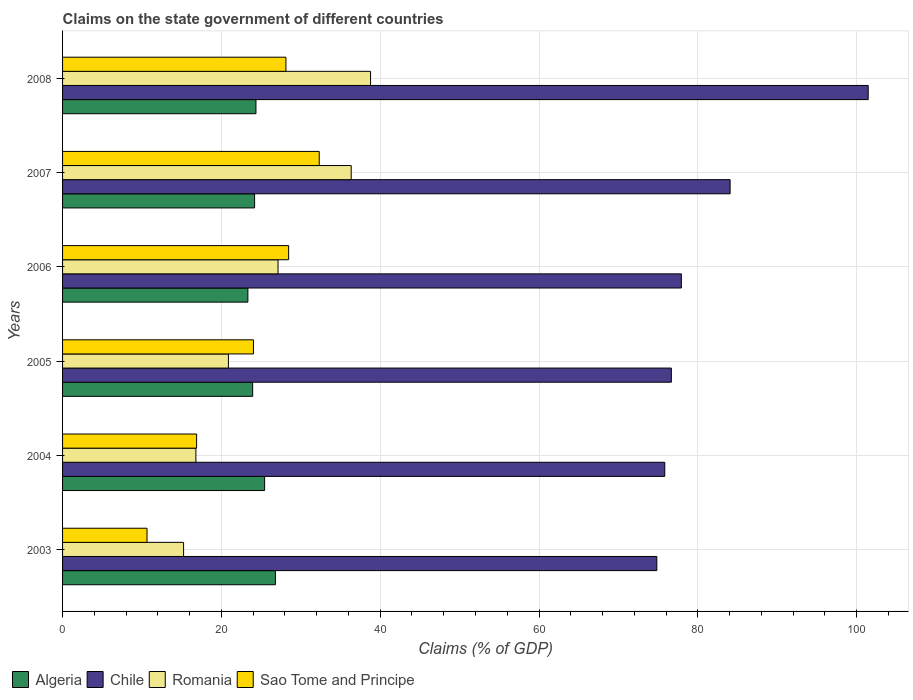How many groups of bars are there?
Your response must be concise. 6. Are the number of bars per tick equal to the number of legend labels?
Keep it short and to the point. Yes. How many bars are there on the 2nd tick from the top?
Your response must be concise. 4. What is the label of the 6th group of bars from the top?
Your answer should be compact. 2003. In how many cases, is the number of bars for a given year not equal to the number of legend labels?
Give a very brief answer. 0. What is the percentage of GDP claimed on the state government in Algeria in 2006?
Provide a short and direct response. 23.33. Across all years, what is the maximum percentage of GDP claimed on the state government in Algeria?
Your answer should be compact. 26.8. Across all years, what is the minimum percentage of GDP claimed on the state government in Algeria?
Your answer should be very brief. 23.33. In which year was the percentage of GDP claimed on the state government in Sao Tome and Principe maximum?
Give a very brief answer. 2007. What is the total percentage of GDP claimed on the state government in Romania in the graph?
Your response must be concise. 155.18. What is the difference between the percentage of GDP claimed on the state government in Sao Tome and Principe in 2007 and that in 2008?
Offer a very short reply. 4.2. What is the difference between the percentage of GDP claimed on the state government in Algeria in 2004 and the percentage of GDP claimed on the state government in Sao Tome and Principe in 2007?
Keep it short and to the point. -6.88. What is the average percentage of GDP claimed on the state government in Algeria per year?
Provide a short and direct response. 24.68. In the year 2004, what is the difference between the percentage of GDP claimed on the state government in Algeria and percentage of GDP claimed on the state government in Sao Tome and Principe?
Give a very brief answer. 8.56. What is the ratio of the percentage of GDP claimed on the state government in Romania in 2004 to that in 2007?
Provide a short and direct response. 0.46. Is the percentage of GDP claimed on the state government in Sao Tome and Principe in 2003 less than that in 2007?
Your answer should be compact. Yes. What is the difference between the highest and the second highest percentage of GDP claimed on the state government in Sao Tome and Principe?
Keep it short and to the point. 3.85. What is the difference between the highest and the lowest percentage of GDP claimed on the state government in Romania?
Provide a short and direct response. 23.55. In how many years, is the percentage of GDP claimed on the state government in Algeria greater than the average percentage of GDP claimed on the state government in Algeria taken over all years?
Provide a succinct answer. 2. Is the sum of the percentage of GDP claimed on the state government in Romania in 2004 and 2005 greater than the maximum percentage of GDP claimed on the state government in Algeria across all years?
Your answer should be compact. Yes. Is it the case that in every year, the sum of the percentage of GDP claimed on the state government in Chile and percentage of GDP claimed on the state government in Sao Tome and Principe is greater than the sum of percentage of GDP claimed on the state government in Romania and percentage of GDP claimed on the state government in Algeria?
Your answer should be very brief. Yes. What does the 3rd bar from the top in 2008 represents?
Offer a terse response. Chile. What does the 1st bar from the bottom in 2007 represents?
Offer a very short reply. Algeria. How many bars are there?
Keep it short and to the point. 24. Are all the bars in the graph horizontal?
Provide a succinct answer. Yes. How many years are there in the graph?
Your answer should be very brief. 6. Are the values on the major ticks of X-axis written in scientific E-notation?
Ensure brevity in your answer.  No. Does the graph contain grids?
Provide a short and direct response. Yes. Where does the legend appear in the graph?
Your answer should be compact. Bottom left. How many legend labels are there?
Offer a very short reply. 4. How are the legend labels stacked?
Ensure brevity in your answer.  Horizontal. What is the title of the graph?
Your response must be concise. Claims on the state government of different countries. What is the label or title of the X-axis?
Your response must be concise. Claims (% of GDP). What is the label or title of the Y-axis?
Offer a terse response. Years. What is the Claims (% of GDP) of Algeria in 2003?
Make the answer very short. 26.8. What is the Claims (% of GDP) in Chile in 2003?
Provide a succinct answer. 74.83. What is the Claims (% of GDP) in Romania in 2003?
Offer a terse response. 15.24. What is the Claims (% of GDP) of Sao Tome and Principe in 2003?
Offer a very short reply. 10.64. What is the Claims (% of GDP) in Algeria in 2004?
Your answer should be very brief. 25.44. What is the Claims (% of GDP) in Chile in 2004?
Offer a very short reply. 75.83. What is the Claims (% of GDP) in Romania in 2004?
Your response must be concise. 16.79. What is the Claims (% of GDP) in Sao Tome and Principe in 2004?
Offer a terse response. 16.88. What is the Claims (% of GDP) in Algeria in 2005?
Offer a terse response. 23.94. What is the Claims (% of GDP) in Chile in 2005?
Your answer should be compact. 76.66. What is the Claims (% of GDP) of Romania in 2005?
Your response must be concise. 20.89. What is the Claims (% of GDP) of Sao Tome and Principe in 2005?
Offer a very short reply. 24.04. What is the Claims (% of GDP) of Algeria in 2006?
Your response must be concise. 23.33. What is the Claims (% of GDP) in Chile in 2006?
Ensure brevity in your answer.  77.92. What is the Claims (% of GDP) in Romania in 2006?
Keep it short and to the point. 27.13. What is the Claims (% of GDP) in Sao Tome and Principe in 2006?
Make the answer very short. 28.47. What is the Claims (% of GDP) of Algeria in 2007?
Make the answer very short. 24.18. What is the Claims (% of GDP) in Chile in 2007?
Your answer should be compact. 84.06. What is the Claims (% of GDP) in Romania in 2007?
Provide a succinct answer. 36.35. What is the Claims (% of GDP) in Sao Tome and Principe in 2007?
Offer a terse response. 32.32. What is the Claims (% of GDP) of Algeria in 2008?
Offer a terse response. 24.35. What is the Claims (% of GDP) in Chile in 2008?
Your response must be concise. 101.45. What is the Claims (% of GDP) of Romania in 2008?
Offer a terse response. 38.78. What is the Claims (% of GDP) of Sao Tome and Principe in 2008?
Provide a succinct answer. 28.13. Across all years, what is the maximum Claims (% of GDP) of Algeria?
Ensure brevity in your answer.  26.8. Across all years, what is the maximum Claims (% of GDP) in Chile?
Your answer should be compact. 101.45. Across all years, what is the maximum Claims (% of GDP) in Romania?
Provide a succinct answer. 38.78. Across all years, what is the maximum Claims (% of GDP) of Sao Tome and Principe?
Offer a very short reply. 32.32. Across all years, what is the minimum Claims (% of GDP) of Algeria?
Your answer should be very brief. 23.33. Across all years, what is the minimum Claims (% of GDP) of Chile?
Make the answer very short. 74.83. Across all years, what is the minimum Claims (% of GDP) in Romania?
Your answer should be compact. 15.24. Across all years, what is the minimum Claims (% of GDP) in Sao Tome and Principe?
Your answer should be very brief. 10.64. What is the total Claims (% of GDP) of Algeria in the graph?
Offer a terse response. 148.05. What is the total Claims (% of GDP) of Chile in the graph?
Provide a short and direct response. 490.76. What is the total Claims (% of GDP) of Romania in the graph?
Make the answer very short. 155.18. What is the total Claims (% of GDP) in Sao Tome and Principe in the graph?
Your response must be concise. 140.47. What is the difference between the Claims (% of GDP) of Algeria in 2003 and that in 2004?
Offer a very short reply. 1.36. What is the difference between the Claims (% of GDP) in Chile in 2003 and that in 2004?
Keep it short and to the point. -1. What is the difference between the Claims (% of GDP) in Romania in 2003 and that in 2004?
Make the answer very short. -1.55. What is the difference between the Claims (% of GDP) in Sao Tome and Principe in 2003 and that in 2004?
Offer a terse response. -6.24. What is the difference between the Claims (% of GDP) of Algeria in 2003 and that in 2005?
Give a very brief answer. 2.86. What is the difference between the Claims (% of GDP) in Chile in 2003 and that in 2005?
Give a very brief answer. -1.83. What is the difference between the Claims (% of GDP) of Romania in 2003 and that in 2005?
Give a very brief answer. -5.65. What is the difference between the Claims (% of GDP) of Sao Tome and Principe in 2003 and that in 2005?
Give a very brief answer. -13.4. What is the difference between the Claims (% of GDP) of Algeria in 2003 and that in 2006?
Ensure brevity in your answer.  3.47. What is the difference between the Claims (% of GDP) in Chile in 2003 and that in 2006?
Give a very brief answer. -3.09. What is the difference between the Claims (% of GDP) in Romania in 2003 and that in 2006?
Provide a short and direct response. -11.89. What is the difference between the Claims (% of GDP) of Sao Tome and Principe in 2003 and that in 2006?
Your answer should be compact. -17.83. What is the difference between the Claims (% of GDP) in Algeria in 2003 and that in 2007?
Give a very brief answer. 2.62. What is the difference between the Claims (% of GDP) in Chile in 2003 and that in 2007?
Offer a terse response. -9.23. What is the difference between the Claims (% of GDP) in Romania in 2003 and that in 2007?
Ensure brevity in your answer.  -21.11. What is the difference between the Claims (% of GDP) in Sao Tome and Principe in 2003 and that in 2007?
Provide a short and direct response. -21.69. What is the difference between the Claims (% of GDP) in Algeria in 2003 and that in 2008?
Provide a short and direct response. 2.45. What is the difference between the Claims (% of GDP) in Chile in 2003 and that in 2008?
Ensure brevity in your answer.  -26.62. What is the difference between the Claims (% of GDP) in Romania in 2003 and that in 2008?
Offer a very short reply. -23.55. What is the difference between the Claims (% of GDP) in Sao Tome and Principe in 2003 and that in 2008?
Offer a very short reply. -17.49. What is the difference between the Claims (% of GDP) in Algeria in 2004 and that in 2005?
Your response must be concise. 1.51. What is the difference between the Claims (% of GDP) of Chile in 2004 and that in 2005?
Provide a short and direct response. -0.83. What is the difference between the Claims (% of GDP) of Romania in 2004 and that in 2005?
Give a very brief answer. -4.1. What is the difference between the Claims (% of GDP) in Sao Tome and Principe in 2004 and that in 2005?
Your answer should be compact. -7.16. What is the difference between the Claims (% of GDP) of Algeria in 2004 and that in 2006?
Provide a short and direct response. 2.11. What is the difference between the Claims (% of GDP) in Chile in 2004 and that in 2006?
Your answer should be compact. -2.09. What is the difference between the Claims (% of GDP) of Romania in 2004 and that in 2006?
Make the answer very short. -10.34. What is the difference between the Claims (% of GDP) in Sao Tome and Principe in 2004 and that in 2006?
Offer a terse response. -11.59. What is the difference between the Claims (% of GDP) of Algeria in 2004 and that in 2007?
Keep it short and to the point. 1.26. What is the difference between the Claims (% of GDP) of Chile in 2004 and that in 2007?
Your answer should be very brief. -8.23. What is the difference between the Claims (% of GDP) in Romania in 2004 and that in 2007?
Ensure brevity in your answer.  -19.56. What is the difference between the Claims (% of GDP) in Sao Tome and Principe in 2004 and that in 2007?
Keep it short and to the point. -15.44. What is the difference between the Claims (% of GDP) in Algeria in 2004 and that in 2008?
Provide a succinct answer. 1.09. What is the difference between the Claims (% of GDP) of Chile in 2004 and that in 2008?
Provide a succinct answer. -25.62. What is the difference between the Claims (% of GDP) of Romania in 2004 and that in 2008?
Offer a very short reply. -22. What is the difference between the Claims (% of GDP) of Sao Tome and Principe in 2004 and that in 2008?
Offer a terse response. -11.25. What is the difference between the Claims (% of GDP) in Algeria in 2005 and that in 2006?
Offer a terse response. 0.6. What is the difference between the Claims (% of GDP) of Chile in 2005 and that in 2006?
Make the answer very short. -1.26. What is the difference between the Claims (% of GDP) of Romania in 2005 and that in 2006?
Make the answer very short. -6.25. What is the difference between the Claims (% of GDP) in Sao Tome and Principe in 2005 and that in 2006?
Provide a short and direct response. -4.43. What is the difference between the Claims (% of GDP) of Algeria in 2005 and that in 2007?
Offer a very short reply. -0.24. What is the difference between the Claims (% of GDP) in Chile in 2005 and that in 2007?
Offer a terse response. -7.4. What is the difference between the Claims (% of GDP) of Romania in 2005 and that in 2007?
Keep it short and to the point. -15.46. What is the difference between the Claims (% of GDP) in Sao Tome and Principe in 2005 and that in 2007?
Give a very brief answer. -8.29. What is the difference between the Claims (% of GDP) of Algeria in 2005 and that in 2008?
Keep it short and to the point. -0.41. What is the difference between the Claims (% of GDP) of Chile in 2005 and that in 2008?
Provide a succinct answer. -24.79. What is the difference between the Claims (% of GDP) of Romania in 2005 and that in 2008?
Your answer should be compact. -17.9. What is the difference between the Claims (% of GDP) in Sao Tome and Principe in 2005 and that in 2008?
Offer a terse response. -4.09. What is the difference between the Claims (% of GDP) in Algeria in 2006 and that in 2007?
Your answer should be compact. -0.85. What is the difference between the Claims (% of GDP) in Chile in 2006 and that in 2007?
Your response must be concise. -6.14. What is the difference between the Claims (% of GDP) of Romania in 2006 and that in 2007?
Ensure brevity in your answer.  -9.21. What is the difference between the Claims (% of GDP) of Sao Tome and Principe in 2006 and that in 2007?
Ensure brevity in your answer.  -3.85. What is the difference between the Claims (% of GDP) of Algeria in 2006 and that in 2008?
Ensure brevity in your answer.  -1.02. What is the difference between the Claims (% of GDP) in Chile in 2006 and that in 2008?
Give a very brief answer. -23.53. What is the difference between the Claims (% of GDP) in Romania in 2006 and that in 2008?
Provide a short and direct response. -11.65. What is the difference between the Claims (% of GDP) in Sao Tome and Principe in 2006 and that in 2008?
Your answer should be compact. 0.34. What is the difference between the Claims (% of GDP) in Algeria in 2007 and that in 2008?
Offer a terse response. -0.17. What is the difference between the Claims (% of GDP) of Chile in 2007 and that in 2008?
Provide a succinct answer. -17.39. What is the difference between the Claims (% of GDP) in Romania in 2007 and that in 2008?
Keep it short and to the point. -2.44. What is the difference between the Claims (% of GDP) of Sao Tome and Principe in 2007 and that in 2008?
Make the answer very short. 4.2. What is the difference between the Claims (% of GDP) in Algeria in 2003 and the Claims (% of GDP) in Chile in 2004?
Give a very brief answer. -49.03. What is the difference between the Claims (% of GDP) of Algeria in 2003 and the Claims (% of GDP) of Romania in 2004?
Offer a very short reply. 10.01. What is the difference between the Claims (% of GDP) in Algeria in 2003 and the Claims (% of GDP) in Sao Tome and Principe in 2004?
Offer a terse response. 9.92. What is the difference between the Claims (% of GDP) in Chile in 2003 and the Claims (% of GDP) in Romania in 2004?
Your answer should be compact. 58.04. What is the difference between the Claims (% of GDP) of Chile in 2003 and the Claims (% of GDP) of Sao Tome and Principe in 2004?
Ensure brevity in your answer.  57.95. What is the difference between the Claims (% of GDP) in Romania in 2003 and the Claims (% of GDP) in Sao Tome and Principe in 2004?
Ensure brevity in your answer.  -1.64. What is the difference between the Claims (% of GDP) of Algeria in 2003 and the Claims (% of GDP) of Chile in 2005?
Your answer should be very brief. -49.86. What is the difference between the Claims (% of GDP) of Algeria in 2003 and the Claims (% of GDP) of Romania in 2005?
Give a very brief answer. 5.92. What is the difference between the Claims (% of GDP) in Algeria in 2003 and the Claims (% of GDP) in Sao Tome and Principe in 2005?
Give a very brief answer. 2.77. What is the difference between the Claims (% of GDP) of Chile in 2003 and the Claims (% of GDP) of Romania in 2005?
Provide a short and direct response. 53.95. What is the difference between the Claims (% of GDP) in Chile in 2003 and the Claims (% of GDP) in Sao Tome and Principe in 2005?
Ensure brevity in your answer.  50.8. What is the difference between the Claims (% of GDP) of Romania in 2003 and the Claims (% of GDP) of Sao Tome and Principe in 2005?
Your answer should be compact. -8.8. What is the difference between the Claims (% of GDP) of Algeria in 2003 and the Claims (% of GDP) of Chile in 2006?
Your response must be concise. -51.12. What is the difference between the Claims (% of GDP) in Algeria in 2003 and the Claims (% of GDP) in Romania in 2006?
Your answer should be compact. -0.33. What is the difference between the Claims (% of GDP) in Algeria in 2003 and the Claims (% of GDP) in Sao Tome and Principe in 2006?
Ensure brevity in your answer.  -1.67. What is the difference between the Claims (% of GDP) of Chile in 2003 and the Claims (% of GDP) of Romania in 2006?
Your answer should be compact. 47.7. What is the difference between the Claims (% of GDP) of Chile in 2003 and the Claims (% of GDP) of Sao Tome and Principe in 2006?
Your answer should be very brief. 46.36. What is the difference between the Claims (% of GDP) of Romania in 2003 and the Claims (% of GDP) of Sao Tome and Principe in 2006?
Your response must be concise. -13.23. What is the difference between the Claims (% of GDP) of Algeria in 2003 and the Claims (% of GDP) of Chile in 2007?
Your answer should be compact. -57.26. What is the difference between the Claims (% of GDP) in Algeria in 2003 and the Claims (% of GDP) in Romania in 2007?
Provide a succinct answer. -9.54. What is the difference between the Claims (% of GDP) in Algeria in 2003 and the Claims (% of GDP) in Sao Tome and Principe in 2007?
Your answer should be compact. -5.52. What is the difference between the Claims (% of GDP) of Chile in 2003 and the Claims (% of GDP) of Romania in 2007?
Your answer should be compact. 38.49. What is the difference between the Claims (% of GDP) in Chile in 2003 and the Claims (% of GDP) in Sao Tome and Principe in 2007?
Give a very brief answer. 42.51. What is the difference between the Claims (% of GDP) of Romania in 2003 and the Claims (% of GDP) of Sao Tome and Principe in 2007?
Give a very brief answer. -17.08. What is the difference between the Claims (% of GDP) in Algeria in 2003 and the Claims (% of GDP) in Chile in 2008?
Offer a terse response. -74.65. What is the difference between the Claims (% of GDP) in Algeria in 2003 and the Claims (% of GDP) in Romania in 2008?
Your response must be concise. -11.98. What is the difference between the Claims (% of GDP) of Algeria in 2003 and the Claims (% of GDP) of Sao Tome and Principe in 2008?
Keep it short and to the point. -1.32. What is the difference between the Claims (% of GDP) of Chile in 2003 and the Claims (% of GDP) of Romania in 2008?
Ensure brevity in your answer.  36.05. What is the difference between the Claims (% of GDP) in Chile in 2003 and the Claims (% of GDP) in Sao Tome and Principe in 2008?
Give a very brief answer. 46.71. What is the difference between the Claims (% of GDP) of Romania in 2003 and the Claims (% of GDP) of Sao Tome and Principe in 2008?
Provide a short and direct response. -12.89. What is the difference between the Claims (% of GDP) in Algeria in 2004 and the Claims (% of GDP) in Chile in 2005?
Keep it short and to the point. -51.22. What is the difference between the Claims (% of GDP) of Algeria in 2004 and the Claims (% of GDP) of Romania in 2005?
Provide a succinct answer. 4.56. What is the difference between the Claims (% of GDP) in Algeria in 2004 and the Claims (% of GDP) in Sao Tome and Principe in 2005?
Your answer should be very brief. 1.41. What is the difference between the Claims (% of GDP) in Chile in 2004 and the Claims (% of GDP) in Romania in 2005?
Provide a short and direct response. 54.94. What is the difference between the Claims (% of GDP) of Chile in 2004 and the Claims (% of GDP) of Sao Tome and Principe in 2005?
Provide a short and direct response. 51.8. What is the difference between the Claims (% of GDP) in Romania in 2004 and the Claims (% of GDP) in Sao Tome and Principe in 2005?
Provide a short and direct response. -7.25. What is the difference between the Claims (% of GDP) in Algeria in 2004 and the Claims (% of GDP) in Chile in 2006?
Offer a very short reply. -52.48. What is the difference between the Claims (% of GDP) in Algeria in 2004 and the Claims (% of GDP) in Romania in 2006?
Provide a short and direct response. -1.69. What is the difference between the Claims (% of GDP) of Algeria in 2004 and the Claims (% of GDP) of Sao Tome and Principe in 2006?
Provide a short and direct response. -3.03. What is the difference between the Claims (% of GDP) of Chile in 2004 and the Claims (% of GDP) of Romania in 2006?
Give a very brief answer. 48.7. What is the difference between the Claims (% of GDP) in Chile in 2004 and the Claims (% of GDP) in Sao Tome and Principe in 2006?
Keep it short and to the point. 47.36. What is the difference between the Claims (% of GDP) in Romania in 2004 and the Claims (% of GDP) in Sao Tome and Principe in 2006?
Provide a succinct answer. -11.68. What is the difference between the Claims (% of GDP) of Algeria in 2004 and the Claims (% of GDP) of Chile in 2007?
Give a very brief answer. -58.62. What is the difference between the Claims (% of GDP) in Algeria in 2004 and the Claims (% of GDP) in Romania in 2007?
Keep it short and to the point. -10.9. What is the difference between the Claims (% of GDP) of Algeria in 2004 and the Claims (% of GDP) of Sao Tome and Principe in 2007?
Ensure brevity in your answer.  -6.88. What is the difference between the Claims (% of GDP) in Chile in 2004 and the Claims (% of GDP) in Romania in 2007?
Your response must be concise. 39.48. What is the difference between the Claims (% of GDP) in Chile in 2004 and the Claims (% of GDP) in Sao Tome and Principe in 2007?
Keep it short and to the point. 43.51. What is the difference between the Claims (% of GDP) of Romania in 2004 and the Claims (% of GDP) of Sao Tome and Principe in 2007?
Give a very brief answer. -15.53. What is the difference between the Claims (% of GDP) in Algeria in 2004 and the Claims (% of GDP) in Chile in 2008?
Make the answer very short. -76.01. What is the difference between the Claims (% of GDP) in Algeria in 2004 and the Claims (% of GDP) in Romania in 2008?
Provide a succinct answer. -13.34. What is the difference between the Claims (% of GDP) of Algeria in 2004 and the Claims (% of GDP) of Sao Tome and Principe in 2008?
Provide a short and direct response. -2.68. What is the difference between the Claims (% of GDP) in Chile in 2004 and the Claims (% of GDP) in Romania in 2008?
Keep it short and to the point. 37.05. What is the difference between the Claims (% of GDP) of Chile in 2004 and the Claims (% of GDP) of Sao Tome and Principe in 2008?
Provide a short and direct response. 47.71. What is the difference between the Claims (% of GDP) of Romania in 2004 and the Claims (% of GDP) of Sao Tome and Principe in 2008?
Give a very brief answer. -11.34. What is the difference between the Claims (% of GDP) of Algeria in 2005 and the Claims (% of GDP) of Chile in 2006?
Ensure brevity in your answer.  -53.98. What is the difference between the Claims (% of GDP) of Algeria in 2005 and the Claims (% of GDP) of Romania in 2006?
Offer a very short reply. -3.19. What is the difference between the Claims (% of GDP) in Algeria in 2005 and the Claims (% of GDP) in Sao Tome and Principe in 2006?
Provide a short and direct response. -4.53. What is the difference between the Claims (% of GDP) of Chile in 2005 and the Claims (% of GDP) of Romania in 2006?
Your response must be concise. 49.53. What is the difference between the Claims (% of GDP) of Chile in 2005 and the Claims (% of GDP) of Sao Tome and Principe in 2006?
Offer a terse response. 48.19. What is the difference between the Claims (% of GDP) of Romania in 2005 and the Claims (% of GDP) of Sao Tome and Principe in 2006?
Keep it short and to the point. -7.58. What is the difference between the Claims (% of GDP) of Algeria in 2005 and the Claims (% of GDP) of Chile in 2007?
Make the answer very short. -60.12. What is the difference between the Claims (% of GDP) of Algeria in 2005 and the Claims (% of GDP) of Romania in 2007?
Make the answer very short. -12.41. What is the difference between the Claims (% of GDP) of Algeria in 2005 and the Claims (% of GDP) of Sao Tome and Principe in 2007?
Your response must be concise. -8.38. What is the difference between the Claims (% of GDP) in Chile in 2005 and the Claims (% of GDP) in Romania in 2007?
Make the answer very short. 40.31. What is the difference between the Claims (% of GDP) of Chile in 2005 and the Claims (% of GDP) of Sao Tome and Principe in 2007?
Offer a terse response. 44.34. What is the difference between the Claims (% of GDP) of Romania in 2005 and the Claims (% of GDP) of Sao Tome and Principe in 2007?
Offer a terse response. -11.44. What is the difference between the Claims (% of GDP) of Algeria in 2005 and the Claims (% of GDP) of Chile in 2008?
Provide a short and direct response. -77.51. What is the difference between the Claims (% of GDP) of Algeria in 2005 and the Claims (% of GDP) of Romania in 2008?
Offer a very short reply. -14.85. What is the difference between the Claims (% of GDP) in Algeria in 2005 and the Claims (% of GDP) in Sao Tome and Principe in 2008?
Offer a terse response. -4.19. What is the difference between the Claims (% of GDP) in Chile in 2005 and the Claims (% of GDP) in Romania in 2008?
Provide a succinct answer. 37.88. What is the difference between the Claims (% of GDP) of Chile in 2005 and the Claims (% of GDP) of Sao Tome and Principe in 2008?
Ensure brevity in your answer.  48.54. What is the difference between the Claims (% of GDP) of Romania in 2005 and the Claims (% of GDP) of Sao Tome and Principe in 2008?
Keep it short and to the point. -7.24. What is the difference between the Claims (% of GDP) in Algeria in 2006 and the Claims (% of GDP) in Chile in 2007?
Your response must be concise. -60.73. What is the difference between the Claims (% of GDP) of Algeria in 2006 and the Claims (% of GDP) of Romania in 2007?
Offer a very short reply. -13.01. What is the difference between the Claims (% of GDP) of Algeria in 2006 and the Claims (% of GDP) of Sao Tome and Principe in 2007?
Offer a terse response. -8.99. What is the difference between the Claims (% of GDP) of Chile in 2006 and the Claims (% of GDP) of Romania in 2007?
Ensure brevity in your answer.  41.58. What is the difference between the Claims (% of GDP) of Chile in 2006 and the Claims (% of GDP) of Sao Tome and Principe in 2007?
Your answer should be compact. 45.6. What is the difference between the Claims (% of GDP) of Romania in 2006 and the Claims (% of GDP) of Sao Tome and Principe in 2007?
Make the answer very short. -5.19. What is the difference between the Claims (% of GDP) in Algeria in 2006 and the Claims (% of GDP) in Chile in 2008?
Your response must be concise. -78.12. What is the difference between the Claims (% of GDP) of Algeria in 2006 and the Claims (% of GDP) of Romania in 2008?
Keep it short and to the point. -15.45. What is the difference between the Claims (% of GDP) in Algeria in 2006 and the Claims (% of GDP) in Sao Tome and Principe in 2008?
Your response must be concise. -4.79. What is the difference between the Claims (% of GDP) in Chile in 2006 and the Claims (% of GDP) in Romania in 2008?
Make the answer very short. 39.14. What is the difference between the Claims (% of GDP) in Chile in 2006 and the Claims (% of GDP) in Sao Tome and Principe in 2008?
Provide a short and direct response. 49.8. What is the difference between the Claims (% of GDP) in Romania in 2006 and the Claims (% of GDP) in Sao Tome and Principe in 2008?
Offer a terse response. -0.99. What is the difference between the Claims (% of GDP) in Algeria in 2007 and the Claims (% of GDP) in Chile in 2008?
Your response must be concise. -77.27. What is the difference between the Claims (% of GDP) of Algeria in 2007 and the Claims (% of GDP) of Romania in 2008?
Keep it short and to the point. -14.6. What is the difference between the Claims (% of GDP) of Algeria in 2007 and the Claims (% of GDP) of Sao Tome and Principe in 2008?
Keep it short and to the point. -3.94. What is the difference between the Claims (% of GDP) in Chile in 2007 and the Claims (% of GDP) in Romania in 2008?
Your answer should be compact. 45.28. What is the difference between the Claims (% of GDP) in Chile in 2007 and the Claims (% of GDP) in Sao Tome and Principe in 2008?
Keep it short and to the point. 55.94. What is the difference between the Claims (% of GDP) of Romania in 2007 and the Claims (% of GDP) of Sao Tome and Principe in 2008?
Your answer should be very brief. 8.22. What is the average Claims (% of GDP) in Algeria per year?
Make the answer very short. 24.68. What is the average Claims (% of GDP) of Chile per year?
Provide a succinct answer. 81.79. What is the average Claims (% of GDP) of Romania per year?
Offer a terse response. 25.86. What is the average Claims (% of GDP) in Sao Tome and Principe per year?
Give a very brief answer. 23.41. In the year 2003, what is the difference between the Claims (% of GDP) of Algeria and Claims (% of GDP) of Chile?
Offer a terse response. -48.03. In the year 2003, what is the difference between the Claims (% of GDP) in Algeria and Claims (% of GDP) in Romania?
Ensure brevity in your answer.  11.56. In the year 2003, what is the difference between the Claims (% of GDP) of Algeria and Claims (% of GDP) of Sao Tome and Principe?
Your answer should be compact. 16.17. In the year 2003, what is the difference between the Claims (% of GDP) of Chile and Claims (% of GDP) of Romania?
Ensure brevity in your answer.  59.6. In the year 2003, what is the difference between the Claims (% of GDP) of Chile and Claims (% of GDP) of Sao Tome and Principe?
Provide a short and direct response. 64.2. In the year 2003, what is the difference between the Claims (% of GDP) in Romania and Claims (% of GDP) in Sao Tome and Principe?
Your answer should be very brief. 4.6. In the year 2004, what is the difference between the Claims (% of GDP) in Algeria and Claims (% of GDP) in Chile?
Make the answer very short. -50.39. In the year 2004, what is the difference between the Claims (% of GDP) of Algeria and Claims (% of GDP) of Romania?
Offer a very short reply. 8.65. In the year 2004, what is the difference between the Claims (% of GDP) of Algeria and Claims (% of GDP) of Sao Tome and Principe?
Your answer should be compact. 8.56. In the year 2004, what is the difference between the Claims (% of GDP) in Chile and Claims (% of GDP) in Romania?
Make the answer very short. 59.04. In the year 2004, what is the difference between the Claims (% of GDP) of Chile and Claims (% of GDP) of Sao Tome and Principe?
Ensure brevity in your answer.  58.95. In the year 2004, what is the difference between the Claims (% of GDP) of Romania and Claims (% of GDP) of Sao Tome and Principe?
Keep it short and to the point. -0.09. In the year 2005, what is the difference between the Claims (% of GDP) of Algeria and Claims (% of GDP) of Chile?
Your response must be concise. -52.72. In the year 2005, what is the difference between the Claims (% of GDP) of Algeria and Claims (% of GDP) of Romania?
Your answer should be compact. 3.05. In the year 2005, what is the difference between the Claims (% of GDP) in Algeria and Claims (% of GDP) in Sao Tome and Principe?
Offer a terse response. -0.1. In the year 2005, what is the difference between the Claims (% of GDP) in Chile and Claims (% of GDP) in Romania?
Make the answer very short. 55.78. In the year 2005, what is the difference between the Claims (% of GDP) in Chile and Claims (% of GDP) in Sao Tome and Principe?
Offer a terse response. 52.63. In the year 2005, what is the difference between the Claims (% of GDP) of Romania and Claims (% of GDP) of Sao Tome and Principe?
Make the answer very short. -3.15. In the year 2006, what is the difference between the Claims (% of GDP) in Algeria and Claims (% of GDP) in Chile?
Make the answer very short. -54.59. In the year 2006, what is the difference between the Claims (% of GDP) of Algeria and Claims (% of GDP) of Romania?
Provide a succinct answer. -3.8. In the year 2006, what is the difference between the Claims (% of GDP) in Algeria and Claims (% of GDP) in Sao Tome and Principe?
Your response must be concise. -5.14. In the year 2006, what is the difference between the Claims (% of GDP) of Chile and Claims (% of GDP) of Romania?
Your answer should be very brief. 50.79. In the year 2006, what is the difference between the Claims (% of GDP) of Chile and Claims (% of GDP) of Sao Tome and Principe?
Give a very brief answer. 49.45. In the year 2006, what is the difference between the Claims (% of GDP) in Romania and Claims (% of GDP) in Sao Tome and Principe?
Your response must be concise. -1.34. In the year 2007, what is the difference between the Claims (% of GDP) of Algeria and Claims (% of GDP) of Chile?
Make the answer very short. -59.88. In the year 2007, what is the difference between the Claims (% of GDP) of Algeria and Claims (% of GDP) of Romania?
Make the answer very short. -12.17. In the year 2007, what is the difference between the Claims (% of GDP) of Algeria and Claims (% of GDP) of Sao Tome and Principe?
Keep it short and to the point. -8.14. In the year 2007, what is the difference between the Claims (% of GDP) in Chile and Claims (% of GDP) in Romania?
Provide a succinct answer. 47.71. In the year 2007, what is the difference between the Claims (% of GDP) of Chile and Claims (% of GDP) of Sao Tome and Principe?
Offer a very short reply. 51.74. In the year 2007, what is the difference between the Claims (% of GDP) in Romania and Claims (% of GDP) in Sao Tome and Principe?
Offer a terse response. 4.03. In the year 2008, what is the difference between the Claims (% of GDP) of Algeria and Claims (% of GDP) of Chile?
Your answer should be compact. -77.1. In the year 2008, what is the difference between the Claims (% of GDP) of Algeria and Claims (% of GDP) of Romania?
Provide a succinct answer. -14.43. In the year 2008, what is the difference between the Claims (% of GDP) in Algeria and Claims (% of GDP) in Sao Tome and Principe?
Provide a short and direct response. -3.77. In the year 2008, what is the difference between the Claims (% of GDP) of Chile and Claims (% of GDP) of Romania?
Offer a terse response. 62.67. In the year 2008, what is the difference between the Claims (% of GDP) in Chile and Claims (% of GDP) in Sao Tome and Principe?
Offer a very short reply. 73.33. In the year 2008, what is the difference between the Claims (% of GDP) of Romania and Claims (% of GDP) of Sao Tome and Principe?
Make the answer very short. 10.66. What is the ratio of the Claims (% of GDP) of Algeria in 2003 to that in 2004?
Provide a succinct answer. 1.05. What is the ratio of the Claims (% of GDP) of Chile in 2003 to that in 2004?
Provide a short and direct response. 0.99. What is the ratio of the Claims (% of GDP) in Romania in 2003 to that in 2004?
Offer a very short reply. 0.91. What is the ratio of the Claims (% of GDP) of Sao Tome and Principe in 2003 to that in 2004?
Your answer should be compact. 0.63. What is the ratio of the Claims (% of GDP) in Algeria in 2003 to that in 2005?
Your response must be concise. 1.12. What is the ratio of the Claims (% of GDP) in Chile in 2003 to that in 2005?
Ensure brevity in your answer.  0.98. What is the ratio of the Claims (% of GDP) of Romania in 2003 to that in 2005?
Provide a short and direct response. 0.73. What is the ratio of the Claims (% of GDP) of Sao Tome and Principe in 2003 to that in 2005?
Give a very brief answer. 0.44. What is the ratio of the Claims (% of GDP) in Algeria in 2003 to that in 2006?
Your response must be concise. 1.15. What is the ratio of the Claims (% of GDP) of Chile in 2003 to that in 2006?
Offer a very short reply. 0.96. What is the ratio of the Claims (% of GDP) of Romania in 2003 to that in 2006?
Offer a terse response. 0.56. What is the ratio of the Claims (% of GDP) of Sao Tome and Principe in 2003 to that in 2006?
Keep it short and to the point. 0.37. What is the ratio of the Claims (% of GDP) of Algeria in 2003 to that in 2007?
Ensure brevity in your answer.  1.11. What is the ratio of the Claims (% of GDP) in Chile in 2003 to that in 2007?
Provide a succinct answer. 0.89. What is the ratio of the Claims (% of GDP) in Romania in 2003 to that in 2007?
Provide a succinct answer. 0.42. What is the ratio of the Claims (% of GDP) in Sao Tome and Principe in 2003 to that in 2007?
Offer a terse response. 0.33. What is the ratio of the Claims (% of GDP) of Algeria in 2003 to that in 2008?
Keep it short and to the point. 1.1. What is the ratio of the Claims (% of GDP) in Chile in 2003 to that in 2008?
Make the answer very short. 0.74. What is the ratio of the Claims (% of GDP) in Romania in 2003 to that in 2008?
Make the answer very short. 0.39. What is the ratio of the Claims (% of GDP) in Sao Tome and Principe in 2003 to that in 2008?
Provide a short and direct response. 0.38. What is the ratio of the Claims (% of GDP) in Algeria in 2004 to that in 2005?
Make the answer very short. 1.06. What is the ratio of the Claims (% of GDP) in Chile in 2004 to that in 2005?
Keep it short and to the point. 0.99. What is the ratio of the Claims (% of GDP) in Romania in 2004 to that in 2005?
Give a very brief answer. 0.8. What is the ratio of the Claims (% of GDP) in Sao Tome and Principe in 2004 to that in 2005?
Provide a succinct answer. 0.7. What is the ratio of the Claims (% of GDP) of Algeria in 2004 to that in 2006?
Provide a short and direct response. 1.09. What is the ratio of the Claims (% of GDP) of Chile in 2004 to that in 2006?
Offer a terse response. 0.97. What is the ratio of the Claims (% of GDP) of Romania in 2004 to that in 2006?
Offer a very short reply. 0.62. What is the ratio of the Claims (% of GDP) of Sao Tome and Principe in 2004 to that in 2006?
Provide a succinct answer. 0.59. What is the ratio of the Claims (% of GDP) of Algeria in 2004 to that in 2007?
Your response must be concise. 1.05. What is the ratio of the Claims (% of GDP) in Chile in 2004 to that in 2007?
Offer a terse response. 0.9. What is the ratio of the Claims (% of GDP) in Romania in 2004 to that in 2007?
Your response must be concise. 0.46. What is the ratio of the Claims (% of GDP) of Sao Tome and Principe in 2004 to that in 2007?
Offer a very short reply. 0.52. What is the ratio of the Claims (% of GDP) of Algeria in 2004 to that in 2008?
Provide a short and direct response. 1.04. What is the ratio of the Claims (% of GDP) of Chile in 2004 to that in 2008?
Provide a short and direct response. 0.75. What is the ratio of the Claims (% of GDP) of Romania in 2004 to that in 2008?
Provide a short and direct response. 0.43. What is the ratio of the Claims (% of GDP) in Sao Tome and Principe in 2004 to that in 2008?
Provide a short and direct response. 0.6. What is the ratio of the Claims (% of GDP) in Algeria in 2005 to that in 2006?
Ensure brevity in your answer.  1.03. What is the ratio of the Claims (% of GDP) in Chile in 2005 to that in 2006?
Your answer should be very brief. 0.98. What is the ratio of the Claims (% of GDP) in Romania in 2005 to that in 2006?
Give a very brief answer. 0.77. What is the ratio of the Claims (% of GDP) in Sao Tome and Principe in 2005 to that in 2006?
Provide a succinct answer. 0.84. What is the ratio of the Claims (% of GDP) of Algeria in 2005 to that in 2007?
Your response must be concise. 0.99. What is the ratio of the Claims (% of GDP) in Chile in 2005 to that in 2007?
Provide a short and direct response. 0.91. What is the ratio of the Claims (% of GDP) in Romania in 2005 to that in 2007?
Keep it short and to the point. 0.57. What is the ratio of the Claims (% of GDP) of Sao Tome and Principe in 2005 to that in 2007?
Your response must be concise. 0.74. What is the ratio of the Claims (% of GDP) in Algeria in 2005 to that in 2008?
Keep it short and to the point. 0.98. What is the ratio of the Claims (% of GDP) of Chile in 2005 to that in 2008?
Offer a terse response. 0.76. What is the ratio of the Claims (% of GDP) in Romania in 2005 to that in 2008?
Offer a very short reply. 0.54. What is the ratio of the Claims (% of GDP) of Sao Tome and Principe in 2005 to that in 2008?
Your answer should be very brief. 0.85. What is the ratio of the Claims (% of GDP) of Chile in 2006 to that in 2007?
Your answer should be compact. 0.93. What is the ratio of the Claims (% of GDP) of Romania in 2006 to that in 2007?
Provide a succinct answer. 0.75. What is the ratio of the Claims (% of GDP) of Sao Tome and Principe in 2006 to that in 2007?
Your answer should be very brief. 0.88. What is the ratio of the Claims (% of GDP) in Algeria in 2006 to that in 2008?
Your response must be concise. 0.96. What is the ratio of the Claims (% of GDP) in Chile in 2006 to that in 2008?
Offer a very short reply. 0.77. What is the ratio of the Claims (% of GDP) of Romania in 2006 to that in 2008?
Offer a terse response. 0.7. What is the ratio of the Claims (% of GDP) in Sao Tome and Principe in 2006 to that in 2008?
Provide a succinct answer. 1.01. What is the ratio of the Claims (% of GDP) in Algeria in 2007 to that in 2008?
Give a very brief answer. 0.99. What is the ratio of the Claims (% of GDP) in Chile in 2007 to that in 2008?
Provide a succinct answer. 0.83. What is the ratio of the Claims (% of GDP) in Romania in 2007 to that in 2008?
Your answer should be compact. 0.94. What is the ratio of the Claims (% of GDP) in Sao Tome and Principe in 2007 to that in 2008?
Provide a succinct answer. 1.15. What is the difference between the highest and the second highest Claims (% of GDP) in Algeria?
Make the answer very short. 1.36. What is the difference between the highest and the second highest Claims (% of GDP) of Chile?
Provide a short and direct response. 17.39. What is the difference between the highest and the second highest Claims (% of GDP) of Romania?
Offer a terse response. 2.44. What is the difference between the highest and the second highest Claims (% of GDP) of Sao Tome and Principe?
Make the answer very short. 3.85. What is the difference between the highest and the lowest Claims (% of GDP) in Algeria?
Provide a succinct answer. 3.47. What is the difference between the highest and the lowest Claims (% of GDP) in Chile?
Ensure brevity in your answer.  26.62. What is the difference between the highest and the lowest Claims (% of GDP) in Romania?
Keep it short and to the point. 23.55. What is the difference between the highest and the lowest Claims (% of GDP) of Sao Tome and Principe?
Offer a terse response. 21.69. 